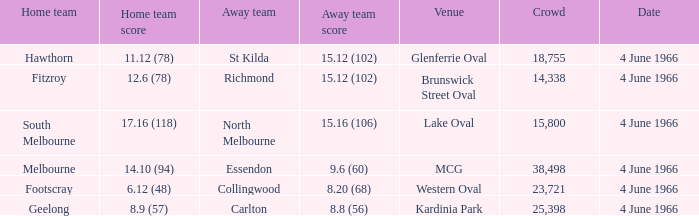What is the score of the away team that played home team Geelong? 8.8 (56). 